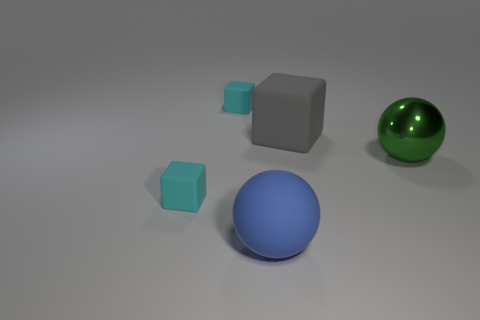Are there any tiny brown metallic balls?
Provide a short and direct response. No. There is a green thing; is its shape the same as the tiny cyan thing that is in front of the green shiny ball?
Your response must be concise. No. There is a matte object that is in front of the small matte block that is to the left of the small object that is behind the big green shiny object; what is its color?
Your response must be concise. Blue. There is a large gray cube; are there any blue balls on the right side of it?
Ensure brevity in your answer.  No. Is there a tiny cube made of the same material as the blue object?
Your response must be concise. Yes. The big matte cube has what color?
Your response must be concise. Gray. There is a small cyan matte thing that is behind the metal thing; is its shape the same as the large gray object?
Your answer should be very brief. Yes. What is the shape of the large rubber thing to the right of the ball on the left side of the large ball behind the large blue sphere?
Provide a short and direct response. Cube. There is a cube right of the large blue thing; what is it made of?
Give a very brief answer. Rubber. There is a ball that is the same size as the green metal object; what color is it?
Your answer should be very brief. Blue. 